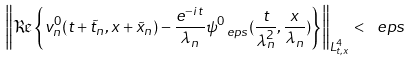Convert formula to latex. <formula><loc_0><loc_0><loc_500><loc_500>\left \| \Re \left \{ v _ { n } ^ { 0 } ( t + \tilde { t } _ { n } , x + \tilde { x } _ { n } ) - \frac { e ^ { - i t } } { \lambda _ { n } } \psi _ { \ e p s } ^ { 0 } ( \frac { t } { \lambda _ { n } ^ { 2 } } , \frac { x } { \lambda _ { n } } ) \right \} \right \| _ { L ^ { 4 } _ { t , x } } < \ e p s</formula> 